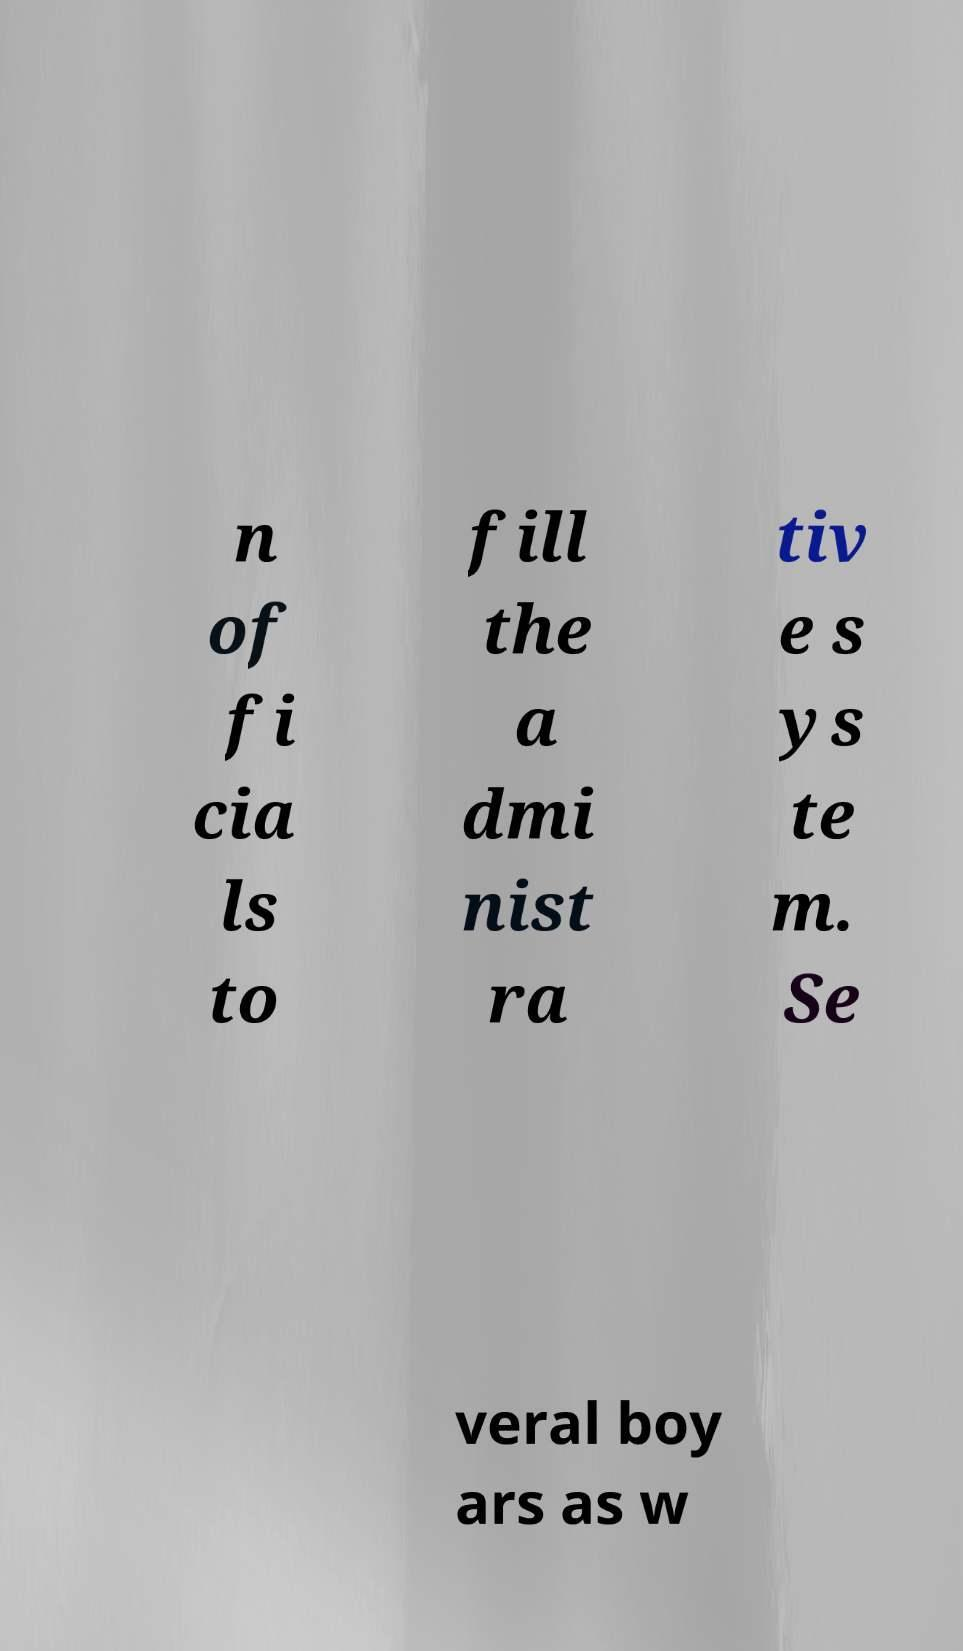Can you accurately transcribe the text from the provided image for me? n of fi cia ls to fill the a dmi nist ra tiv e s ys te m. Se veral boy ars as w 